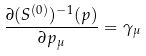Convert formula to latex. <formula><loc_0><loc_0><loc_500><loc_500>\frac { \partial ( S ^ { ( 0 ) } ) ^ { - 1 } ( p ) } { \partial p _ { \mu } } = \gamma _ { \mu }</formula> 